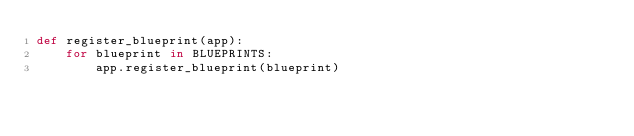<code> <loc_0><loc_0><loc_500><loc_500><_Python_>def register_blueprint(app):
    for blueprint in BLUEPRINTS:
        app.register_blueprint(blueprint)
</code> 